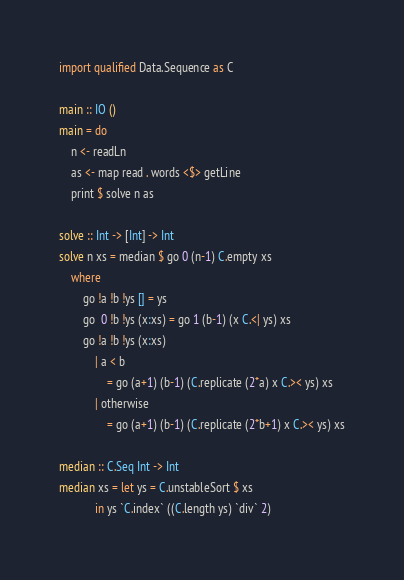<code> <loc_0><loc_0><loc_500><loc_500><_Haskell_>import qualified Data.Sequence as C

main :: IO ()
main = do
    n <- readLn
    as <- map read . words <$> getLine
    print $ solve n as

solve :: Int -> [Int] -> Int
solve n xs = median $ go 0 (n-1) C.empty xs
    where
        go !a !b !ys [] = ys
        go  0 !b !ys (x:xs) = go 1 (b-1) (x C.<| ys) xs
        go !a !b !ys (x:xs)
            | a < b
                = go (a+1) (b-1) (C.replicate (2*a) x C.>< ys) xs
            | otherwise
                = go (a+1) (b-1) (C.replicate (2*b+1) x C.>< ys) xs

median :: C.Seq Int -> Int
median xs = let ys = C.unstableSort $ xs
            in ys `C.index` ((C.length ys) `div` 2)
</code> 